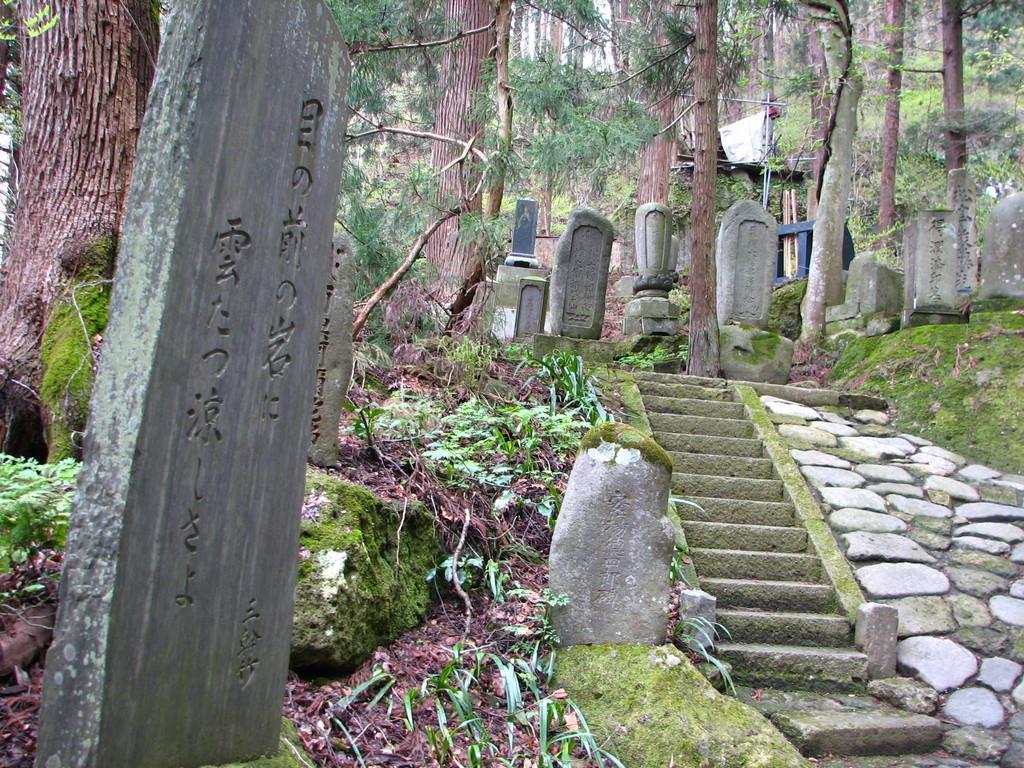Could you give a brief overview of what you see in this image? In this image I can see a concrete pole, few stairs, few trees, few rocks and some grass. In the background I can see few trees and the sky. 